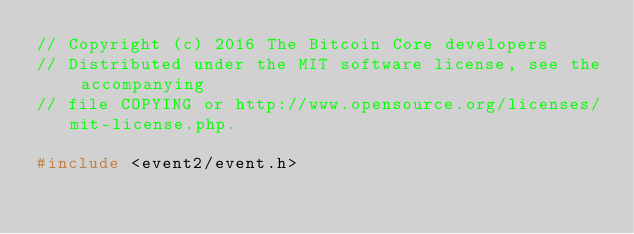<code> <loc_0><loc_0><loc_500><loc_500><_C++_>// Copyright (c) 2016 The Bitcoin Core developers
// Distributed under the MIT software license, see the accompanying
// file COPYING or http://www.opensource.org/licenses/mit-license.php.

#include <event2/event.h>
</code> 